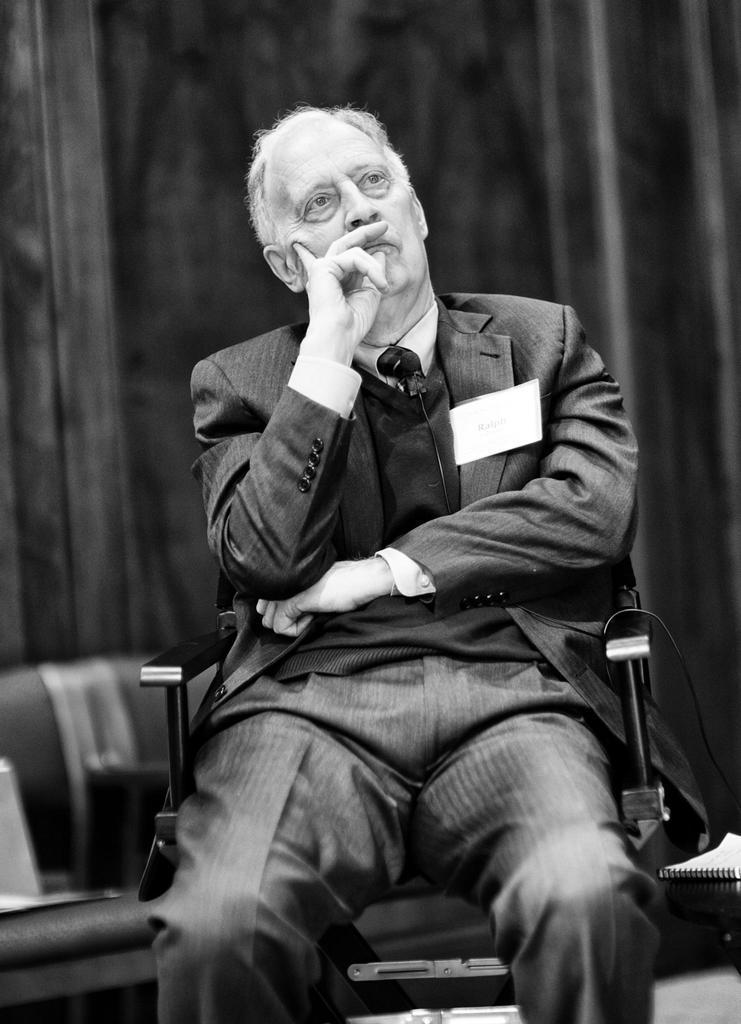Please provide a concise description of this image. In the center of the image we can see a person sitting. In the background there is a wall and there is a chair. 